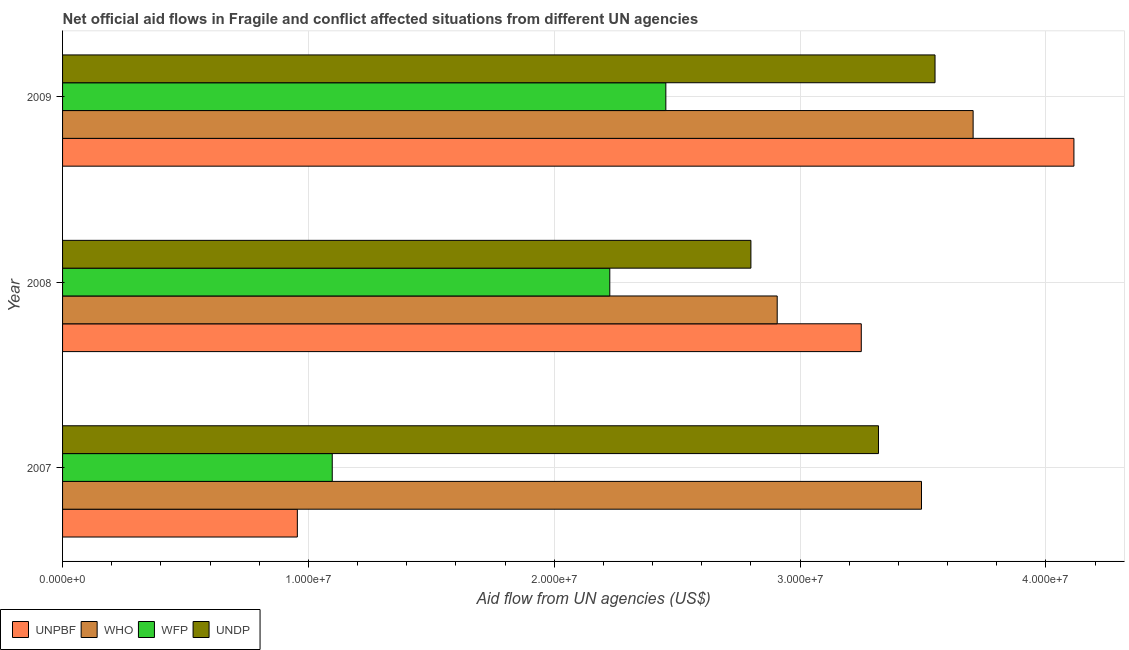How many different coloured bars are there?
Your answer should be very brief. 4. What is the label of the 2nd group of bars from the top?
Make the answer very short. 2008. In how many cases, is the number of bars for a given year not equal to the number of legend labels?
Your response must be concise. 0. What is the amount of aid given by wfp in 2009?
Your answer should be very brief. 2.45e+07. Across all years, what is the maximum amount of aid given by unpbf?
Give a very brief answer. 4.11e+07. Across all years, what is the minimum amount of aid given by who?
Offer a very short reply. 2.91e+07. What is the total amount of aid given by undp in the graph?
Provide a succinct answer. 9.67e+07. What is the difference between the amount of aid given by wfp in 2008 and that in 2009?
Offer a very short reply. -2.28e+06. What is the difference between the amount of aid given by wfp in 2009 and the amount of aid given by undp in 2008?
Make the answer very short. -3.46e+06. What is the average amount of aid given by undp per year?
Your answer should be compact. 3.22e+07. In the year 2008, what is the difference between the amount of aid given by who and amount of aid given by unpbf?
Your answer should be compact. -3.42e+06. What is the ratio of the amount of aid given by undp in 2008 to that in 2009?
Keep it short and to the point. 0.79. Is the amount of aid given by who in 2007 less than that in 2008?
Make the answer very short. No. What is the difference between the highest and the second highest amount of aid given by who?
Offer a very short reply. 2.10e+06. What is the difference between the highest and the lowest amount of aid given by unpbf?
Ensure brevity in your answer.  3.16e+07. Is the sum of the amount of aid given by unpbf in 2007 and 2008 greater than the maximum amount of aid given by wfp across all years?
Your response must be concise. Yes. What does the 2nd bar from the top in 2009 represents?
Give a very brief answer. WFP. What does the 2nd bar from the bottom in 2008 represents?
Your answer should be very brief. WHO. Is it the case that in every year, the sum of the amount of aid given by unpbf and amount of aid given by who is greater than the amount of aid given by wfp?
Offer a terse response. Yes. How many bars are there?
Make the answer very short. 12. Are all the bars in the graph horizontal?
Keep it short and to the point. Yes. How many years are there in the graph?
Your response must be concise. 3. Where does the legend appear in the graph?
Your answer should be very brief. Bottom left. How are the legend labels stacked?
Your response must be concise. Horizontal. What is the title of the graph?
Your answer should be compact. Net official aid flows in Fragile and conflict affected situations from different UN agencies. What is the label or title of the X-axis?
Your answer should be very brief. Aid flow from UN agencies (US$). What is the label or title of the Y-axis?
Ensure brevity in your answer.  Year. What is the Aid flow from UN agencies (US$) of UNPBF in 2007?
Provide a short and direct response. 9.55e+06. What is the Aid flow from UN agencies (US$) of WHO in 2007?
Ensure brevity in your answer.  3.49e+07. What is the Aid flow from UN agencies (US$) of WFP in 2007?
Your answer should be very brief. 1.10e+07. What is the Aid flow from UN agencies (US$) of UNDP in 2007?
Keep it short and to the point. 3.32e+07. What is the Aid flow from UN agencies (US$) in UNPBF in 2008?
Ensure brevity in your answer.  3.25e+07. What is the Aid flow from UN agencies (US$) in WHO in 2008?
Offer a very short reply. 2.91e+07. What is the Aid flow from UN agencies (US$) in WFP in 2008?
Your response must be concise. 2.23e+07. What is the Aid flow from UN agencies (US$) of UNDP in 2008?
Provide a succinct answer. 2.80e+07. What is the Aid flow from UN agencies (US$) in UNPBF in 2009?
Your response must be concise. 4.11e+07. What is the Aid flow from UN agencies (US$) of WHO in 2009?
Offer a very short reply. 3.70e+07. What is the Aid flow from UN agencies (US$) in WFP in 2009?
Offer a very short reply. 2.45e+07. What is the Aid flow from UN agencies (US$) of UNDP in 2009?
Give a very brief answer. 3.55e+07. Across all years, what is the maximum Aid flow from UN agencies (US$) in UNPBF?
Give a very brief answer. 4.11e+07. Across all years, what is the maximum Aid flow from UN agencies (US$) of WHO?
Offer a terse response. 3.70e+07. Across all years, what is the maximum Aid flow from UN agencies (US$) in WFP?
Your response must be concise. 2.45e+07. Across all years, what is the maximum Aid flow from UN agencies (US$) in UNDP?
Your answer should be very brief. 3.55e+07. Across all years, what is the minimum Aid flow from UN agencies (US$) of UNPBF?
Your answer should be very brief. 9.55e+06. Across all years, what is the minimum Aid flow from UN agencies (US$) of WHO?
Give a very brief answer. 2.91e+07. Across all years, what is the minimum Aid flow from UN agencies (US$) of WFP?
Keep it short and to the point. 1.10e+07. Across all years, what is the minimum Aid flow from UN agencies (US$) of UNDP?
Give a very brief answer. 2.80e+07. What is the total Aid flow from UN agencies (US$) in UNPBF in the graph?
Offer a terse response. 8.32e+07. What is the total Aid flow from UN agencies (US$) in WHO in the graph?
Your response must be concise. 1.01e+08. What is the total Aid flow from UN agencies (US$) in WFP in the graph?
Offer a very short reply. 5.78e+07. What is the total Aid flow from UN agencies (US$) in UNDP in the graph?
Give a very brief answer. 9.67e+07. What is the difference between the Aid flow from UN agencies (US$) of UNPBF in 2007 and that in 2008?
Your answer should be very brief. -2.29e+07. What is the difference between the Aid flow from UN agencies (US$) of WHO in 2007 and that in 2008?
Make the answer very short. 5.87e+06. What is the difference between the Aid flow from UN agencies (US$) in WFP in 2007 and that in 2008?
Your answer should be compact. -1.13e+07. What is the difference between the Aid flow from UN agencies (US$) of UNDP in 2007 and that in 2008?
Keep it short and to the point. 5.19e+06. What is the difference between the Aid flow from UN agencies (US$) of UNPBF in 2007 and that in 2009?
Offer a very short reply. -3.16e+07. What is the difference between the Aid flow from UN agencies (US$) in WHO in 2007 and that in 2009?
Provide a short and direct response. -2.10e+06. What is the difference between the Aid flow from UN agencies (US$) of WFP in 2007 and that in 2009?
Make the answer very short. -1.36e+07. What is the difference between the Aid flow from UN agencies (US$) in UNDP in 2007 and that in 2009?
Your answer should be compact. -2.30e+06. What is the difference between the Aid flow from UN agencies (US$) in UNPBF in 2008 and that in 2009?
Your response must be concise. -8.65e+06. What is the difference between the Aid flow from UN agencies (US$) of WHO in 2008 and that in 2009?
Keep it short and to the point. -7.97e+06. What is the difference between the Aid flow from UN agencies (US$) in WFP in 2008 and that in 2009?
Ensure brevity in your answer.  -2.28e+06. What is the difference between the Aid flow from UN agencies (US$) in UNDP in 2008 and that in 2009?
Ensure brevity in your answer.  -7.49e+06. What is the difference between the Aid flow from UN agencies (US$) of UNPBF in 2007 and the Aid flow from UN agencies (US$) of WHO in 2008?
Keep it short and to the point. -1.95e+07. What is the difference between the Aid flow from UN agencies (US$) of UNPBF in 2007 and the Aid flow from UN agencies (US$) of WFP in 2008?
Keep it short and to the point. -1.27e+07. What is the difference between the Aid flow from UN agencies (US$) in UNPBF in 2007 and the Aid flow from UN agencies (US$) in UNDP in 2008?
Your answer should be very brief. -1.84e+07. What is the difference between the Aid flow from UN agencies (US$) in WHO in 2007 and the Aid flow from UN agencies (US$) in WFP in 2008?
Your response must be concise. 1.27e+07. What is the difference between the Aid flow from UN agencies (US$) of WHO in 2007 and the Aid flow from UN agencies (US$) of UNDP in 2008?
Give a very brief answer. 6.94e+06. What is the difference between the Aid flow from UN agencies (US$) in WFP in 2007 and the Aid flow from UN agencies (US$) in UNDP in 2008?
Provide a succinct answer. -1.70e+07. What is the difference between the Aid flow from UN agencies (US$) of UNPBF in 2007 and the Aid flow from UN agencies (US$) of WHO in 2009?
Your response must be concise. -2.75e+07. What is the difference between the Aid flow from UN agencies (US$) of UNPBF in 2007 and the Aid flow from UN agencies (US$) of WFP in 2009?
Offer a terse response. -1.50e+07. What is the difference between the Aid flow from UN agencies (US$) in UNPBF in 2007 and the Aid flow from UN agencies (US$) in UNDP in 2009?
Provide a short and direct response. -2.59e+07. What is the difference between the Aid flow from UN agencies (US$) in WHO in 2007 and the Aid flow from UN agencies (US$) in WFP in 2009?
Your answer should be very brief. 1.04e+07. What is the difference between the Aid flow from UN agencies (US$) in WHO in 2007 and the Aid flow from UN agencies (US$) in UNDP in 2009?
Make the answer very short. -5.50e+05. What is the difference between the Aid flow from UN agencies (US$) of WFP in 2007 and the Aid flow from UN agencies (US$) of UNDP in 2009?
Keep it short and to the point. -2.45e+07. What is the difference between the Aid flow from UN agencies (US$) of UNPBF in 2008 and the Aid flow from UN agencies (US$) of WHO in 2009?
Offer a very short reply. -4.55e+06. What is the difference between the Aid flow from UN agencies (US$) in UNPBF in 2008 and the Aid flow from UN agencies (US$) in WFP in 2009?
Make the answer very short. 7.95e+06. What is the difference between the Aid flow from UN agencies (US$) in UNPBF in 2008 and the Aid flow from UN agencies (US$) in UNDP in 2009?
Give a very brief answer. -3.00e+06. What is the difference between the Aid flow from UN agencies (US$) of WHO in 2008 and the Aid flow from UN agencies (US$) of WFP in 2009?
Make the answer very short. 4.53e+06. What is the difference between the Aid flow from UN agencies (US$) of WHO in 2008 and the Aid flow from UN agencies (US$) of UNDP in 2009?
Give a very brief answer. -6.42e+06. What is the difference between the Aid flow from UN agencies (US$) in WFP in 2008 and the Aid flow from UN agencies (US$) in UNDP in 2009?
Ensure brevity in your answer.  -1.32e+07. What is the average Aid flow from UN agencies (US$) of UNPBF per year?
Provide a succinct answer. 2.77e+07. What is the average Aid flow from UN agencies (US$) of WHO per year?
Your response must be concise. 3.37e+07. What is the average Aid flow from UN agencies (US$) of WFP per year?
Offer a terse response. 1.93e+07. What is the average Aid flow from UN agencies (US$) in UNDP per year?
Give a very brief answer. 3.22e+07. In the year 2007, what is the difference between the Aid flow from UN agencies (US$) of UNPBF and Aid flow from UN agencies (US$) of WHO?
Offer a very short reply. -2.54e+07. In the year 2007, what is the difference between the Aid flow from UN agencies (US$) in UNPBF and Aid flow from UN agencies (US$) in WFP?
Your answer should be compact. -1.42e+06. In the year 2007, what is the difference between the Aid flow from UN agencies (US$) of UNPBF and Aid flow from UN agencies (US$) of UNDP?
Keep it short and to the point. -2.36e+07. In the year 2007, what is the difference between the Aid flow from UN agencies (US$) of WHO and Aid flow from UN agencies (US$) of WFP?
Offer a very short reply. 2.40e+07. In the year 2007, what is the difference between the Aid flow from UN agencies (US$) of WHO and Aid flow from UN agencies (US$) of UNDP?
Give a very brief answer. 1.75e+06. In the year 2007, what is the difference between the Aid flow from UN agencies (US$) in WFP and Aid flow from UN agencies (US$) in UNDP?
Your response must be concise. -2.22e+07. In the year 2008, what is the difference between the Aid flow from UN agencies (US$) in UNPBF and Aid flow from UN agencies (US$) in WHO?
Give a very brief answer. 3.42e+06. In the year 2008, what is the difference between the Aid flow from UN agencies (US$) in UNPBF and Aid flow from UN agencies (US$) in WFP?
Offer a very short reply. 1.02e+07. In the year 2008, what is the difference between the Aid flow from UN agencies (US$) in UNPBF and Aid flow from UN agencies (US$) in UNDP?
Make the answer very short. 4.49e+06. In the year 2008, what is the difference between the Aid flow from UN agencies (US$) of WHO and Aid flow from UN agencies (US$) of WFP?
Ensure brevity in your answer.  6.81e+06. In the year 2008, what is the difference between the Aid flow from UN agencies (US$) in WHO and Aid flow from UN agencies (US$) in UNDP?
Your response must be concise. 1.07e+06. In the year 2008, what is the difference between the Aid flow from UN agencies (US$) of WFP and Aid flow from UN agencies (US$) of UNDP?
Your answer should be compact. -5.74e+06. In the year 2009, what is the difference between the Aid flow from UN agencies (US$) in UNPBF and Aid flow from UN agencies (US$) in WHO?
Your response must be concise. 4.10e+06. In the year 2009, what is the difference between the Aid flow from UN agencies (US$) in UNPBF and Aid flow from UN agencies (US$) in WFP?
Your answer should be compact. 1.66e+07. In the year 2009, what is the difference between the Aid flow from UN agencies (US$) of UNPBF and Aid flow from UN agencies (US$) of UNDP?
Offer a very short reply. 5.65e+06. In the year 2009, what is the difference between the Aid flow from UN agencies (US$) in WHO and Aid flow from UN agencies (US$) in WFP?
Your answer should be very brief. 1.25e+07. In the year 2009, what is the difference between the Aid flow from UN agencies (US$) in WHO and Aid flow from UN agencies (US$) in UNDP?
Make the answer very short. 1.55e+06. In the year 2009, what is the difference between the Aid flow from UN agencies (US$) of WFP and Aid flow from UN agencies (US$) of UNDP?
Give a very brief answer. -1.10e+07. What is the ratio of the Aid flow from UN agencies (US$) in UNPBF in 2007 to that in 2008?
Your answer should be very brief. 0.29. What is the ratio of the Aid flow from UN agencies (US$) in WHO in 2007 to that in 2008?
Offer a terse response. 1.2. What is the ratio of the Aid flow from UN agencies (US$) in WFP in 2007 to that in 2008?
Ensure brevity in your answer.  0.49. What is the ratio of the Aid flow from UN agencies (US$) of UNDP in 2007 to that in 2008?
Offer a very short reply. 1.19. What is the ratio of the Aid flow from UN agencies (US$) of UNPBF in 2007 to that in 2009?
Make the answer very short. 0.23. What is the ratio of the Aid flow from UN agencies (US$) in WHO in 2007 to that in 2009?
Provide a succinct answer. 0.94. What is the ratio of the Aid flow from UN agencies (US$) of WFP in 2007 to that in 2009?
Ensure brevity in your answer.  0.45. What is the ratio of the Aid flow from UN agencies (US$) of UNDP in 2007 to that in 2009?
Offer a terse response. 0.94. What is the ratio of the Aid flow from UN agencies (US$) in UNPBF in 2008 to that in 2009?
Ensure brevity in your answer.  0.79. What is the ratio of the Aid flow from UN agencies (US$) of WHO in 2008 to that in 2009?
Ensure brevity in your answer.  0.78. What is the ratio of the Aid flow from UN agencies (US$) of WFP in 2008 to that in 2009?
Offer a terse response. 0.91. What is the ratio of the Aid flow from UN agencies (US$) in UNDP in 2008 to that in 2009?
Your answer should be very brief. 0.79. What is the difference between the highest and the second highest Aid flow from UN agencies (US$) of UNPBF?
Provide a short and direct response. 8.65e+06. What is the difference between the highest and the second highest Aid flow from UN agencies (US$) in WHO?
Your answer should be very brief. 2.10e+06. What is the difference between the highest and the second highest Aid flow from UN agencies (US$) in WFP?
Your answer should be compact. 2.28e+06. What is the difference between the highest and the second highest Aid flow from UN agencies (US$) in UNDP?
Your answer should be compact. 2.30e+06. What is the difference between the highest and the lowest Aid flow from UN agencies (US$) of UNPBF?
Make the answer very short. 3.16e+07. What is the difference between the highest and the lowest Aid flow from UN agencies (US$) in WHO?
Your answer should be very brief. 7.97e+06. What is the difference between the highest and the lowest Aid flow from UN agencies (US$) in WFP?
Your answer should be very brief. 1.36e+07. What is the difference between the highest and the lowest Aid flow from UN agencies (US$) of UNDP?
Your response must be concise. 7.49e+06. 